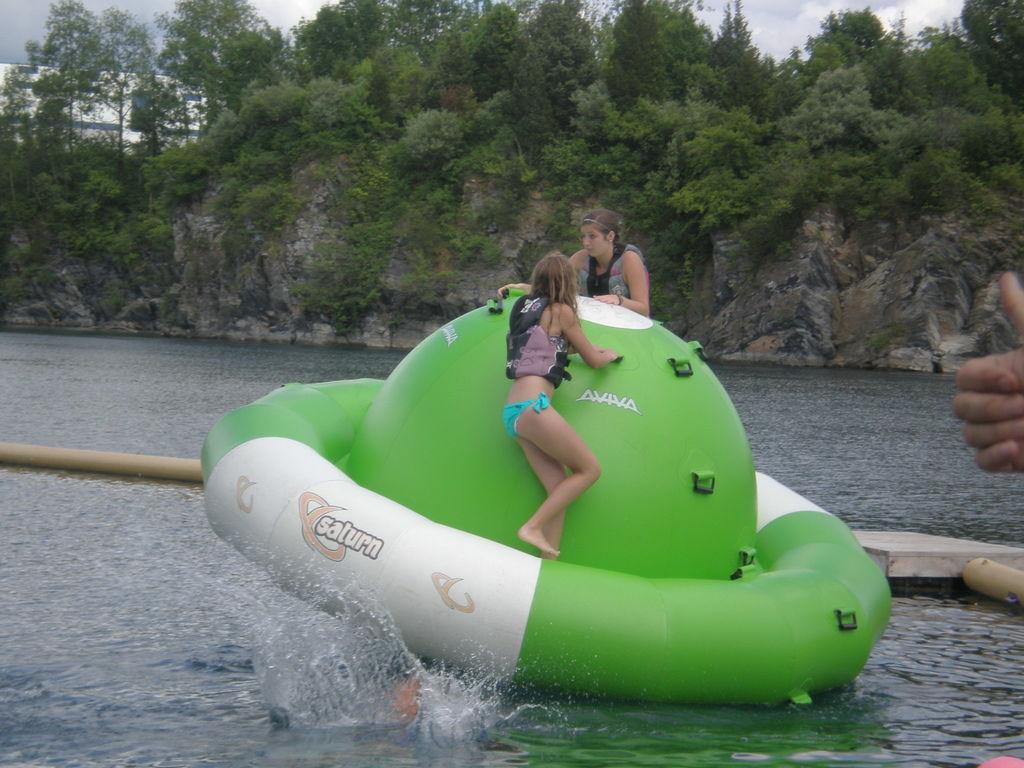Could you give a brief overview of what you see in this image? Here I can see a balloon on the water. On the balloon there are two women. On the right side, I can see a person's hand. In the background there are many trees and a rock. At the top I can see the sky. 